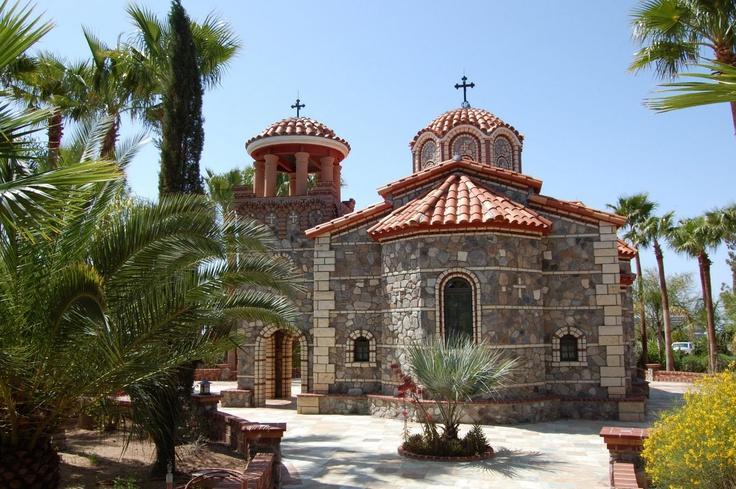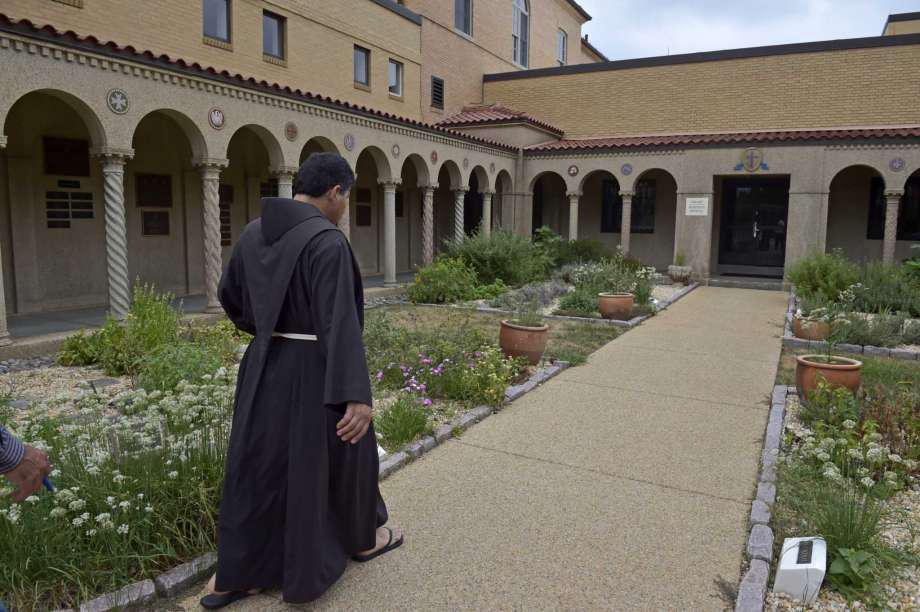The first image is the image on the left, the second image is the image on the right. Given the left and right images, does the statement "There is at least one cross atop the building in one of the images." hold true? Answer yes or no. Yes. The first image is the image on the left, the second image is the image on the right. Analyze the images presented: Is the assertion "There is at least one visible cross atop the building in one of the images." valid? Answer yes or no. Yes. 